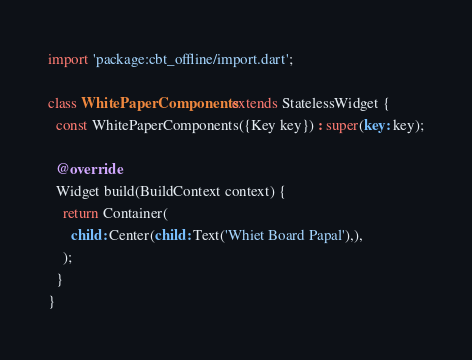Convert code to text. <code><loc_0><loc_0><loc_500><loc_500><_Dart_>import 'package:cbt_offline/import.dart';

class WhitePaperComponents extends StatelessWidget {
  const WhitePaperComponents({Key key}) : super(key: key);

  @override
  Widget build(BuildContext context) {
    return Container(
      child: Center(child: Text('Whiet Board Papal'),),
    );
  }
}</code> 